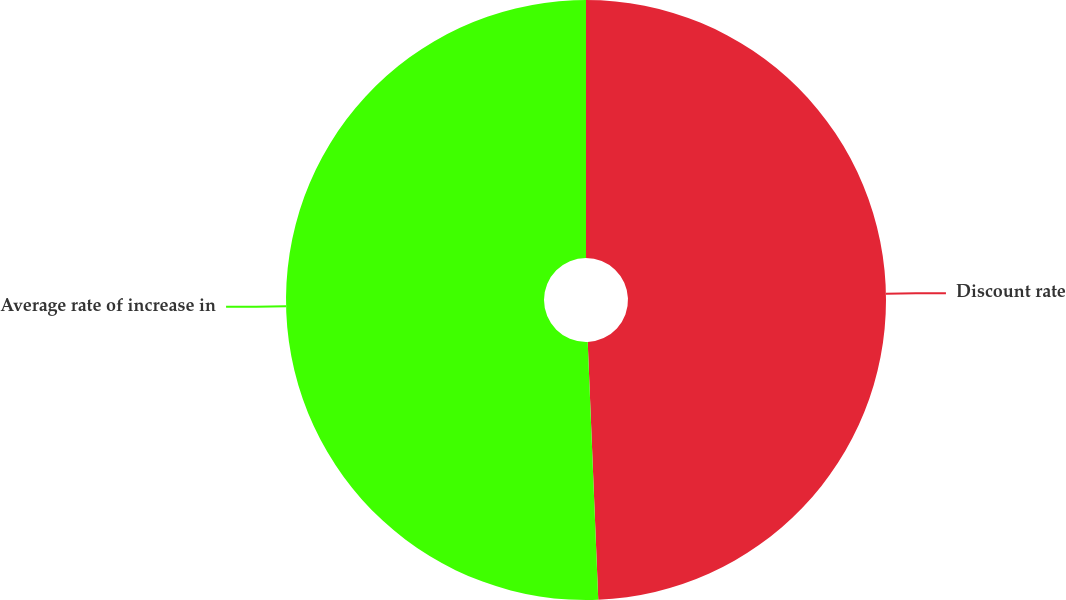Convert chart. <chart><loc_0><loc_0><loc_500><loc_500><pie_chart><fcel>Discount rate<fcel>Average rate of increase in<nl><fcel>49.35%<fcel>50.65%<nl></chart> 